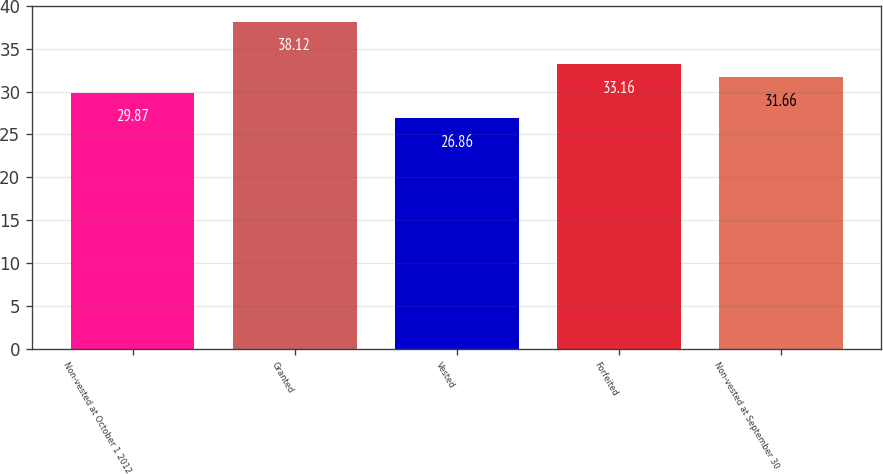<chart> <loc_0><loc_0><loc_500><loc_500><bar_chart><fcel>Non-vested at October 1 2012<fcel>Granted<fcel>Vested<fcel>Forfeited<fcel>Non-vested at September 30<nl><fcel>29.87<fcel>38.12<fcel>26.86<fcel>33.16<fcel>31.66<nl></chart> 